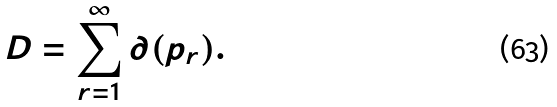<formula> <loc_0><loc_0><loc_500><loc_500>D = \sum _ { r = 1 } ^ { \infty } \partial ( p _ { r } ) .</formula> 